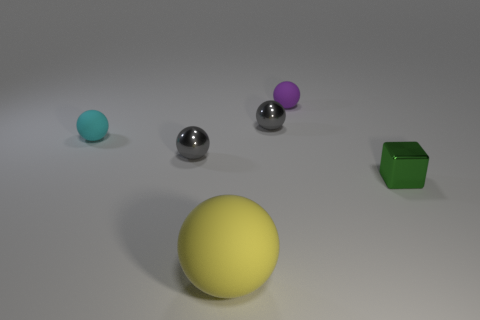There is a rubber object that is both on the right side of the tiny cyan object and behind the yellow sphere; what shape is it?
Offer a very short reply. Sphere. What is the shape of the yellow object that is the same material as the purple ball?
Provide a short and direct response. Sphere. There is a gray ball in front of the small cyan rubber object; what material is it?
Offer a very short reply. Metal. Does the matte object that is left of the yellow matte thing have the same size as the rubber ball that is in front of the shiny cube?
Ensure brevity in your answer.  No. The large object is what color?
Make the answer very short. Yellow. Do the small gray object left of the yellow matte sphere and the tiny cyan object have the same shape?
Keep it short and to the point. Yes. What is the material of the cube?
Make the answer very short. Metal. What shape is the purple object that is the same size as the green cube?
Provide a succinct answer. Sphere. Are there any other large spheres of the same color as the large matte sphere?
Your answer should be compact. No. There is a small metallic cube; is its color the same as the tiny metal ball on the left side of the yellow ball?
Provide a short and direct response. No. 